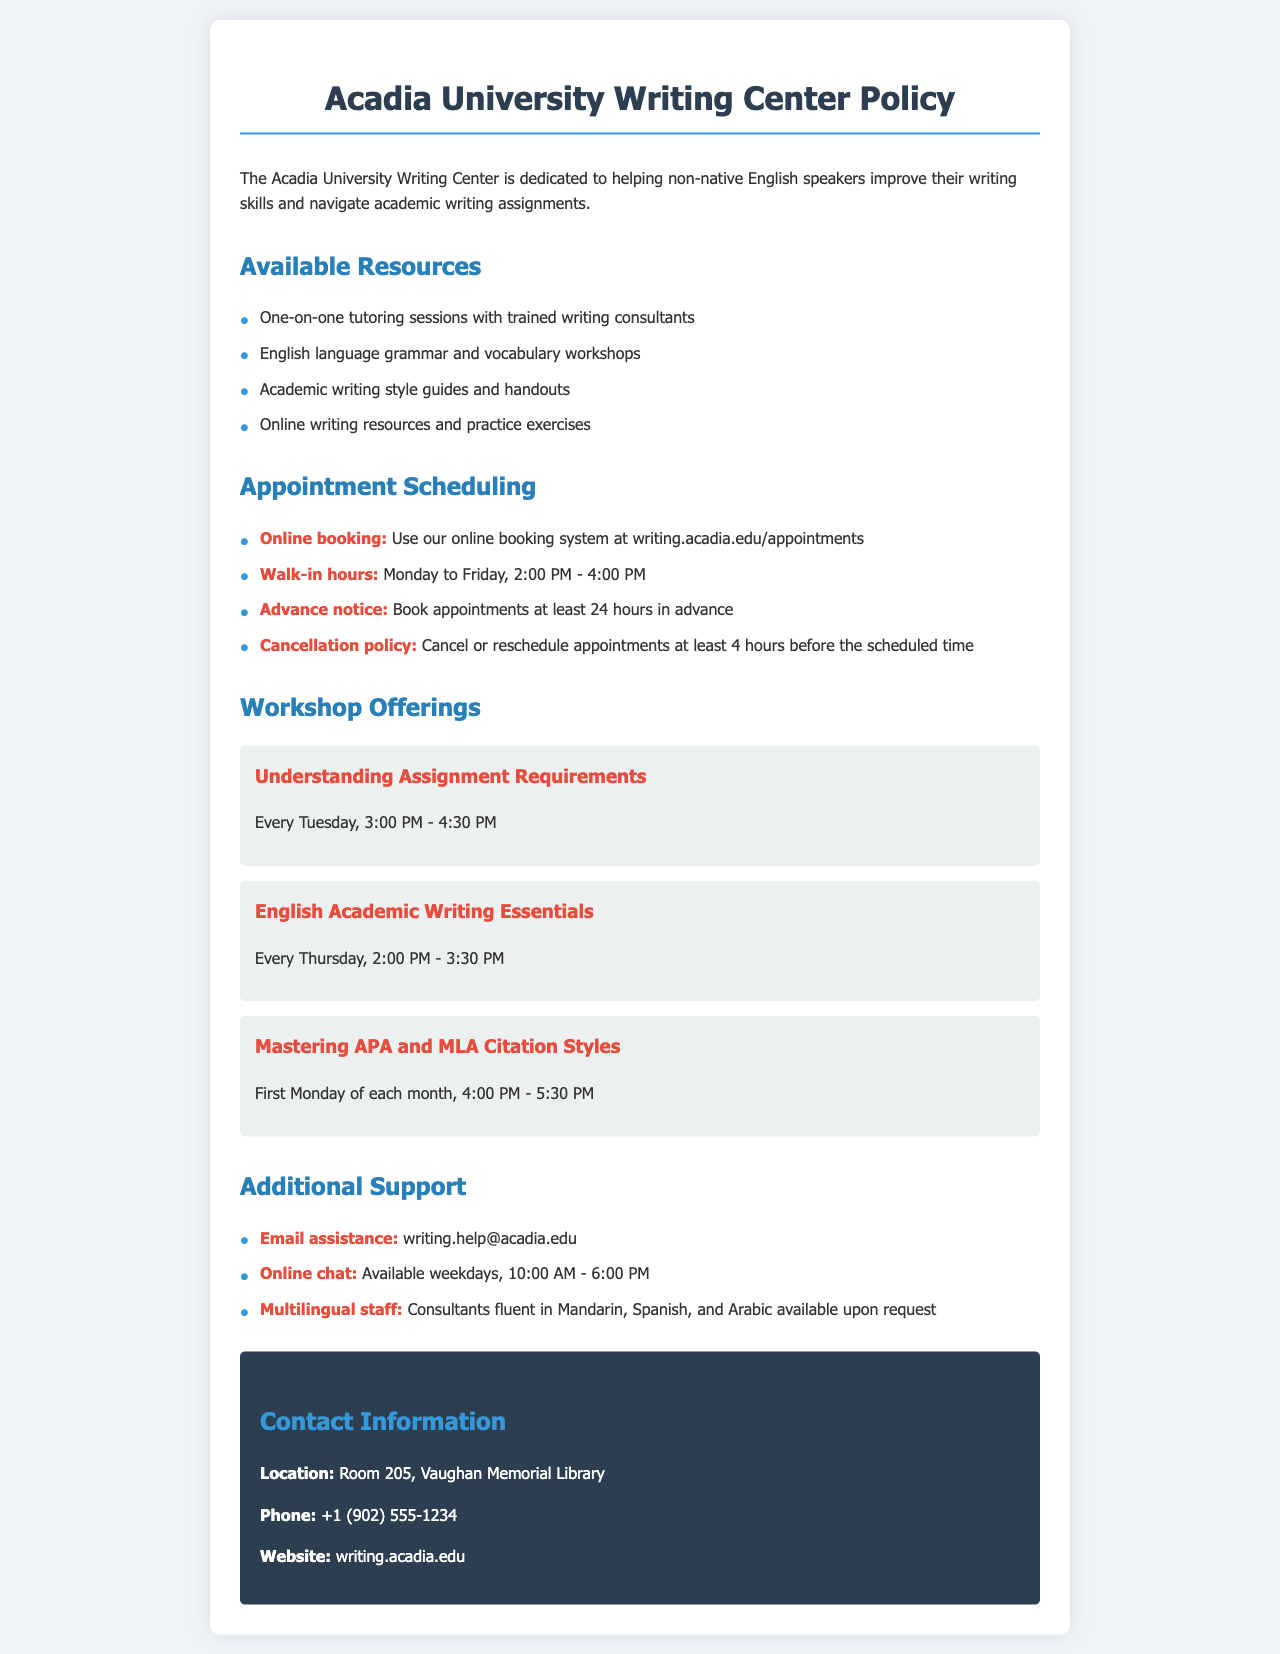What resources does the Writing Center offer? The resources listed include one-on-one tutoring sessions, workshops, writing guides, and online resources.
Answer: One-on-one tutoring sessions, English language grammar and vocabulary workshops, academic writing style guides and handouts, online writing resources and practice exercises When are walk-in hours at the Writing Center? The walk-in hours for the Writing Center are specific times indicated in the document.
Answer: Monday to Friday, 2:00 PM - 4:00 PM How much advance notice is needed for appointments? The document specifies a requirement regarding booking appointments in advance.
Answer: At least 24 hours in advance What is the cancellation policy? The cancellation policy outlines the necessary actions for rescheduling or canceling appointments.
Answer: Cancel or reschedule appointments at least 4 hours before the scheduled time What workshops are offered on Tuesdays? A specific workshop mentioned in the document occurs on Tuesdays, focusing on understanding assignments.
Answer: Understanding Assignment Requirements Which citation styles are covered in the workshops? The document lists specific citation styles included in the workshops offered.
Answer: APA and MLA Citation Styles Is there email assistance available? The document includes information about support via email for students seeking help.
Answer: writing.help@acadia.edu Where can I find the Writing Center's contact information? The document provides a section dedicated to contact details for the Writing Center.
Answer: Room 205, Vaughan Memorial Library 